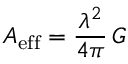Convert formula to latex. <formula><loc_0><loc_0><loc_500><loc_500>A _ { e f f } = { \frac { \lambda ^ { 2 } } { 4 \pi } } \, G</formula> 